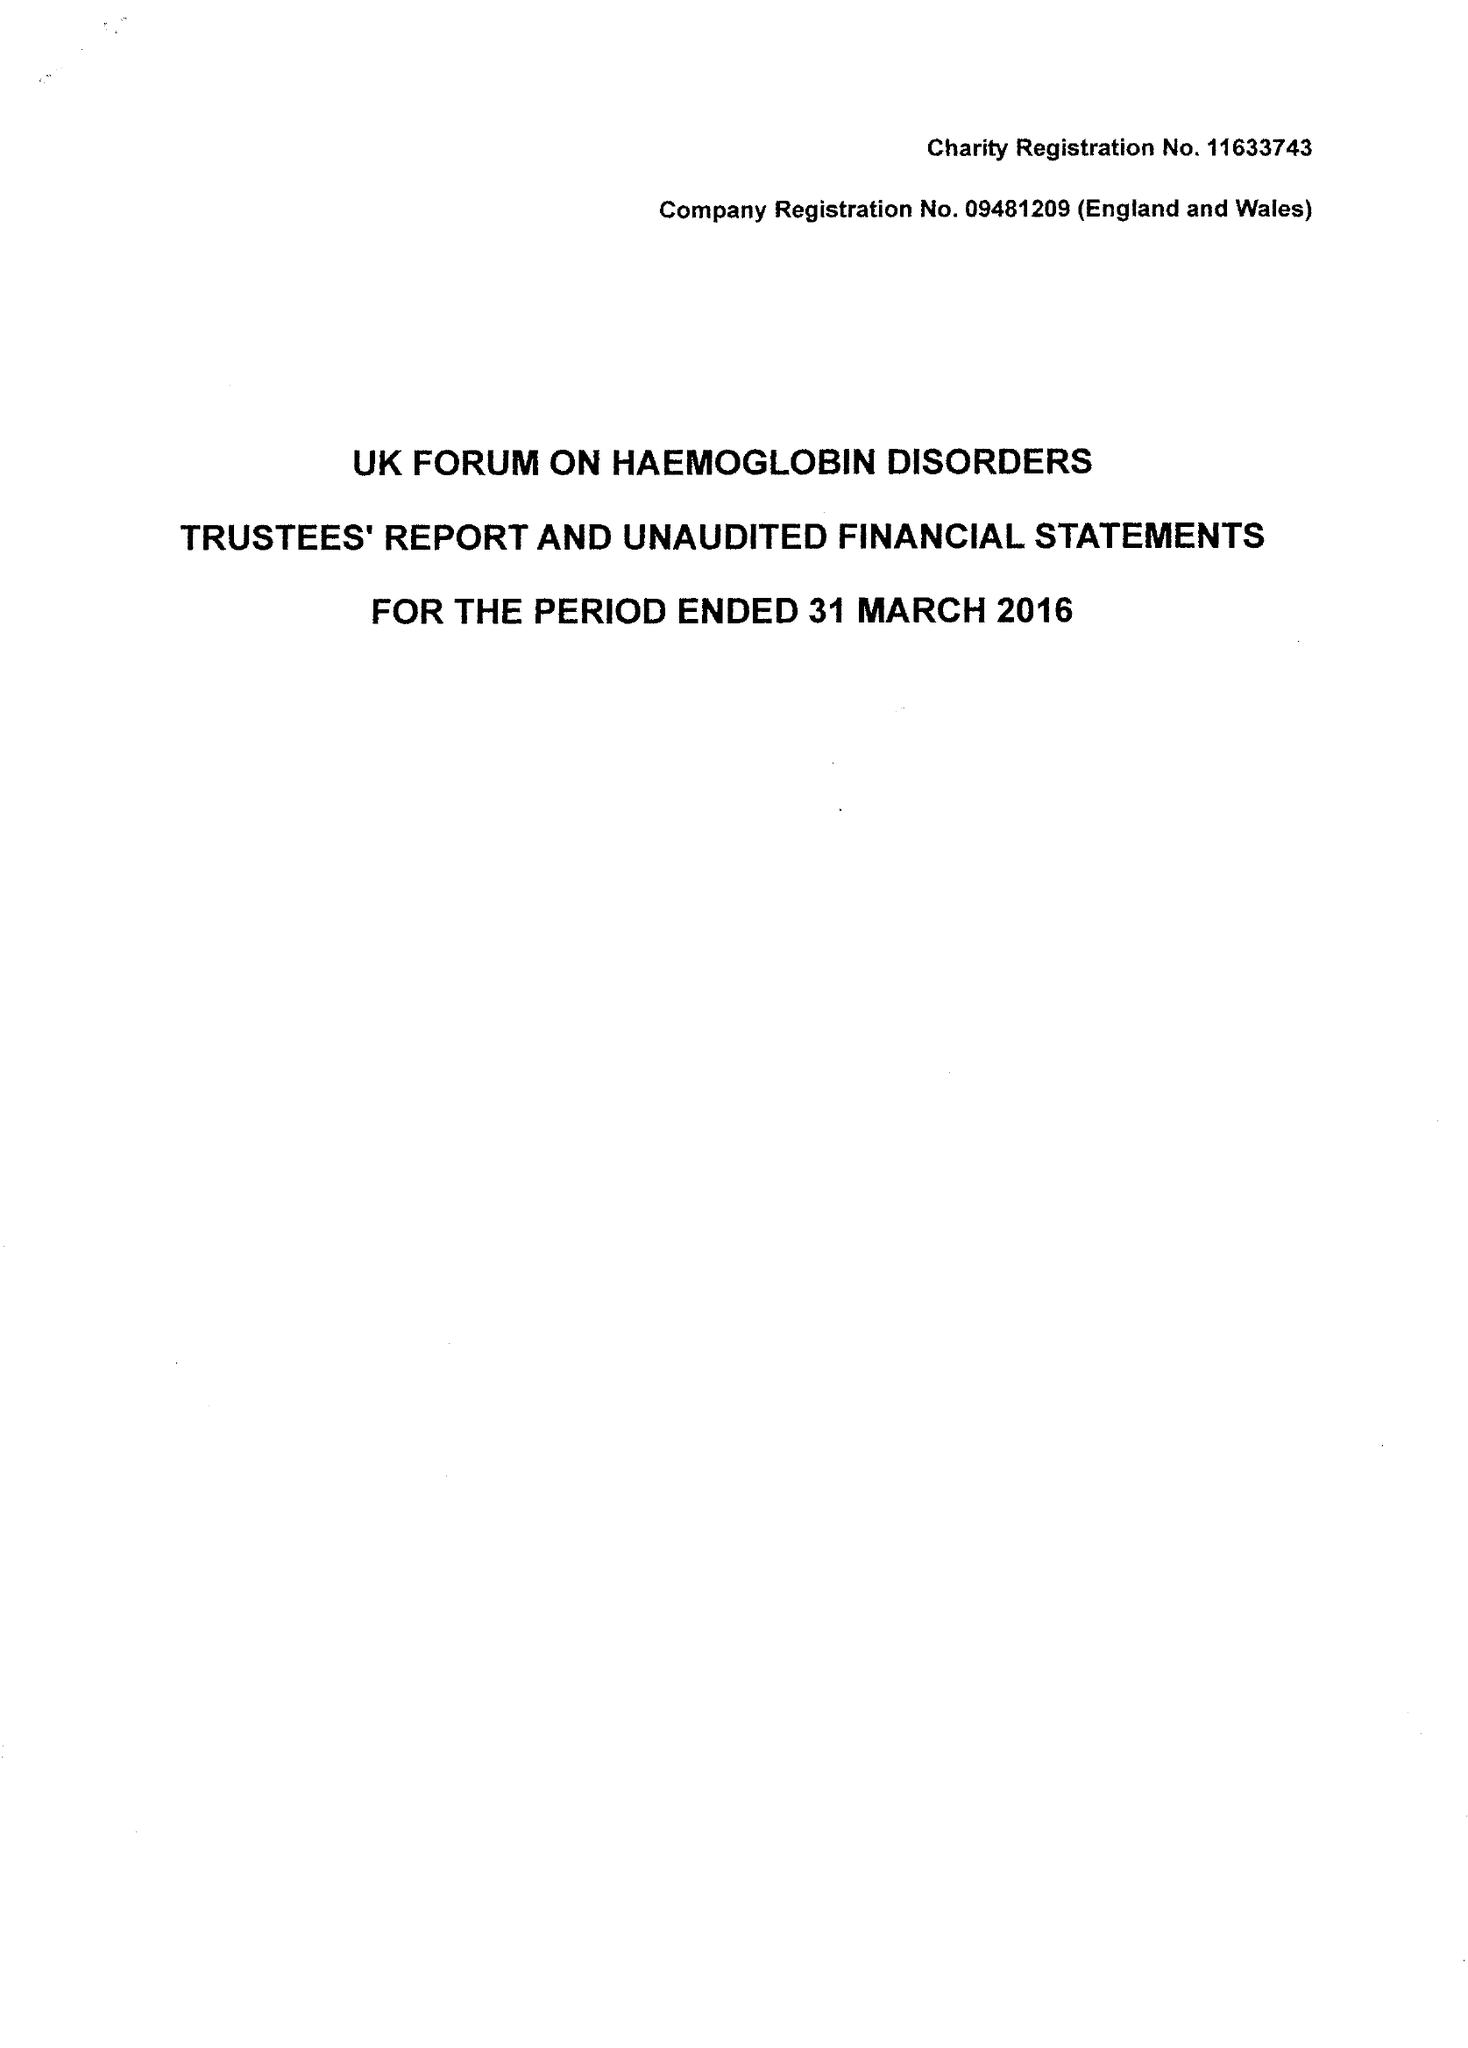What is the value for the report_date?
Answer the question using a single word or phrase. 2016-03-31 